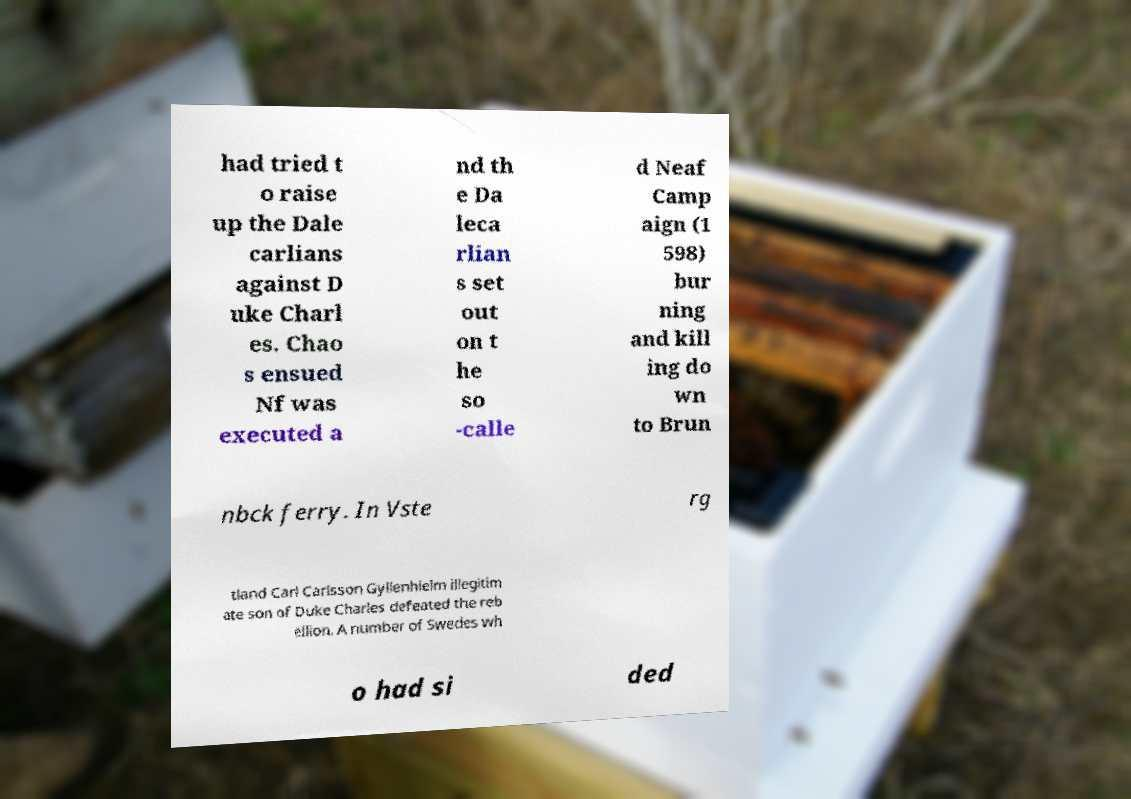Can you accurately transcribe the text from the provided image for me? had tried t o raise up the Dale carlians against D uke Charl es. Chao s ensued Nf was executed a nd th e Da leca rlian s set out on t he so -calle d Neaf Camp aign (1 598) bur ning and kill ing do wn to Brun nbck ferry. In Vste rg tland Carl Carlsson Gyllenhielm illegitim ate son of Duke Charles defeated the reb ellion. A number of Swedes wh o had si ded 